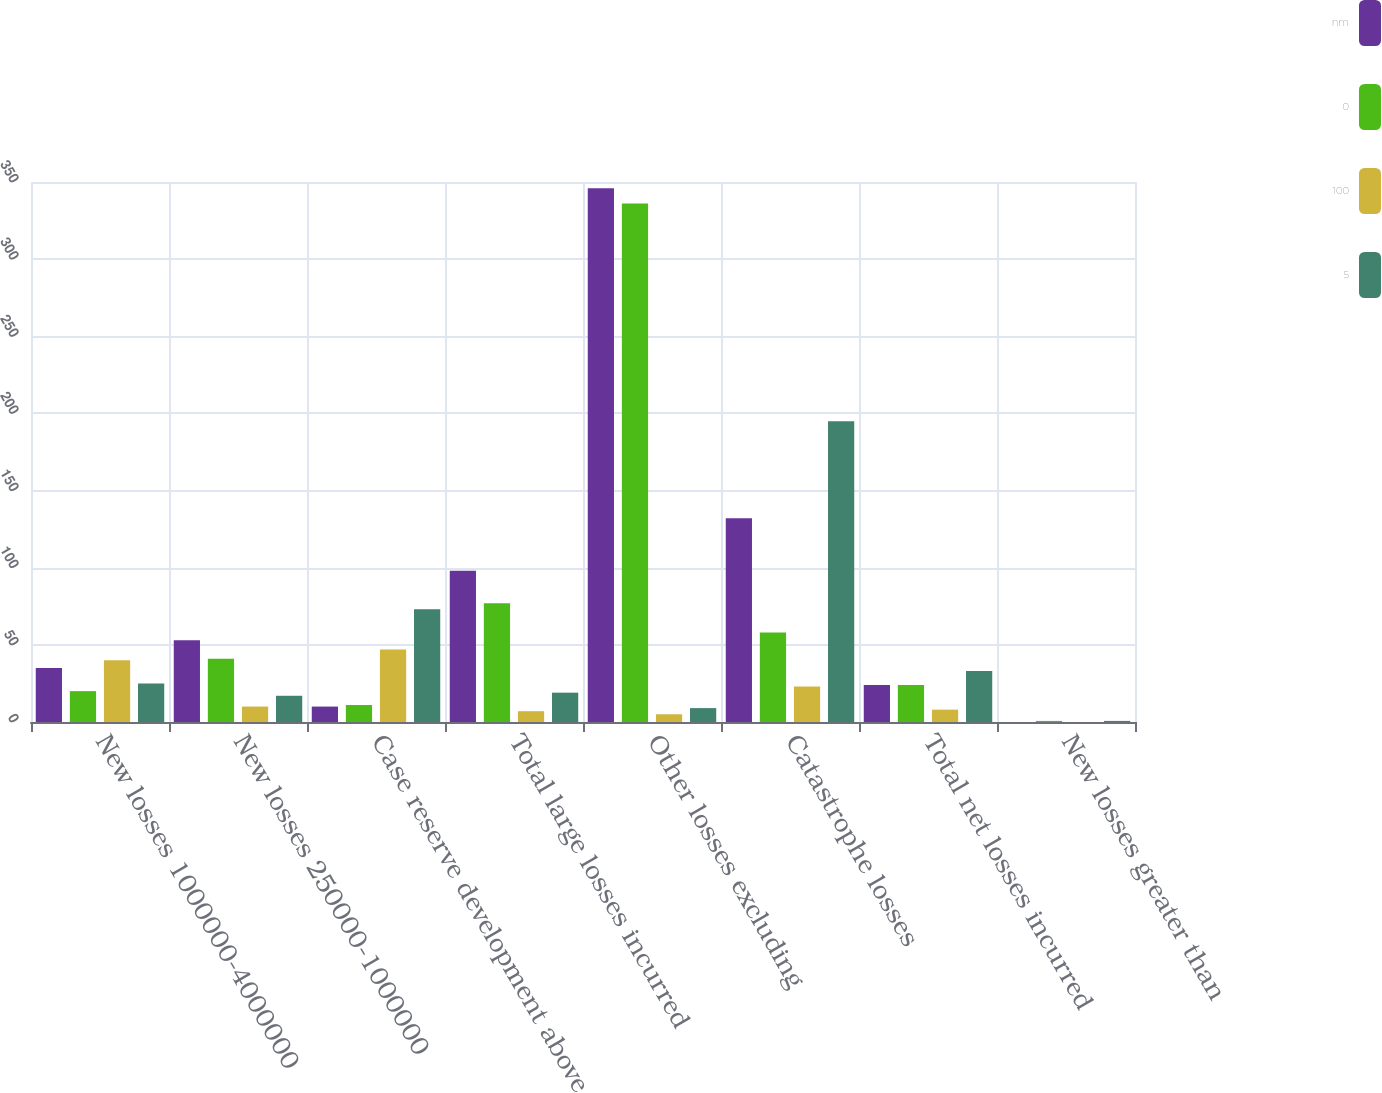Convert chart. <chart><loc_0><loc_0><loc_500><loc_500><stacked_bar_chart><ecel><fcel>New losses 1000000-4000000<fcel>New losses 250000-1000000<fcel>Case reserve development above<fcel>Total large losses incurred<fcel>Other losses excluding<fcel>Catastrophe losses<fcel>Total net losses incurred<fcel>New losses greater than<nl><fcel>nm<fcel>35<fcel>53<fcel>10<fcel>98<fcel>346<fcel>132<fcel>24<fcel>0<nl><fcel>0<fcel>20<fcel>41<fcel>11<fcel>77<fcel>336<fcel>58<fcel>24<fcel>0.7<nl><fcel>100<fcel>40<fcel>10<fcel>47<fcel>7<fcel>5<fcel>23<fcel>8<fcel>0<nl><fcel>5<fcel>25<fcel>17<fcel>73<fcel>19<fcel>9<fcel>195<fcel>33<fcel>0.7<nl></chart> 